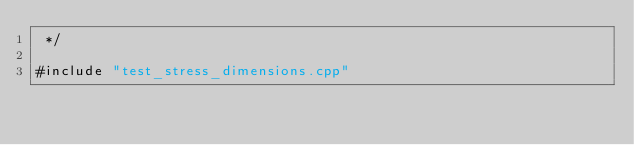Convert code to text. <code><loc_0><loc_0><loc_500><loc_500><_Cuda_> */

#include "test_stress_dimensions.cpp"
</code> 